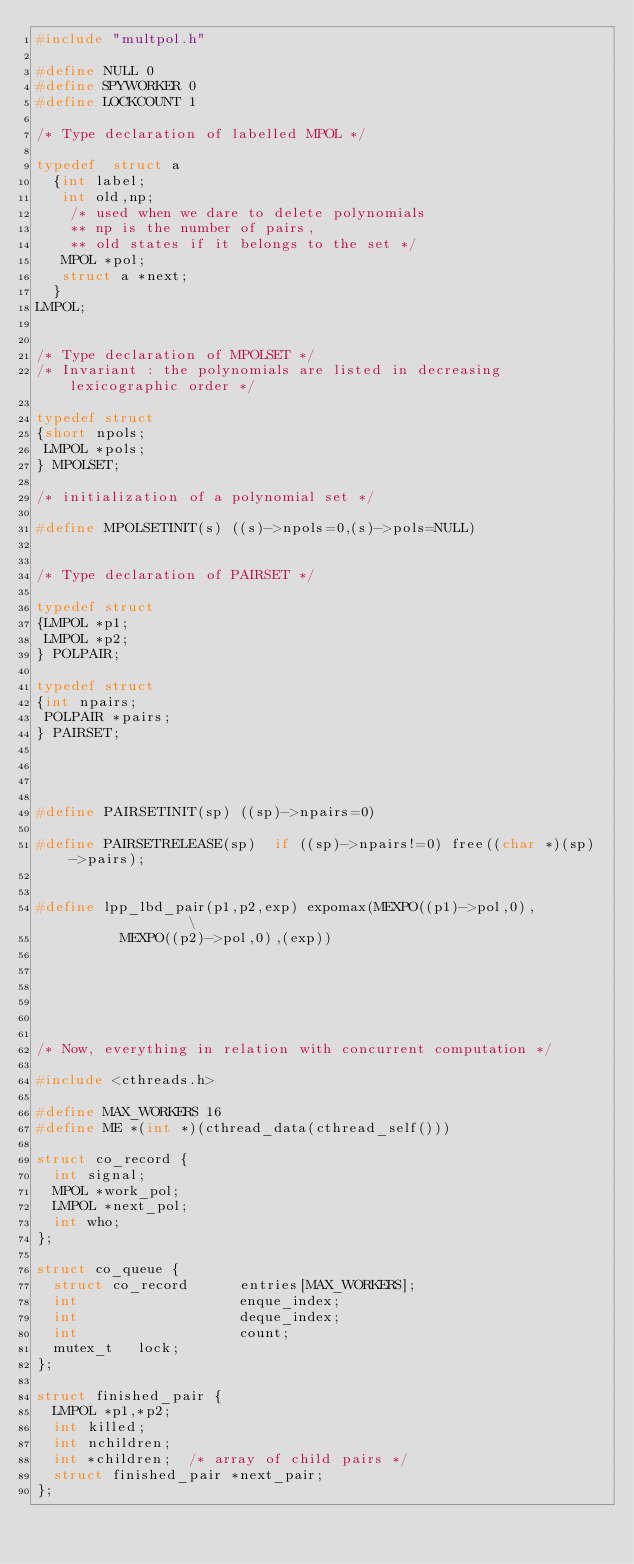Convert code to text. <code><loc_0><loc_0><loc_500><loc_500><_C_>#include "multpol.h"

#define NULL 0
#define SPYWORKER 0
#define LOCKCOUNT 1

/* Type declaration of labelled MPOL */

typedef  struct a
	{int label;
	 int old,np;
		/* used when we dare to delete polynomials 
		** np is the number of pairs, 
		** old states if it belongs to the set */
	 MPOL *pol;
	 struct a *next;
	}
LMPOL;


/* Type declaration of MPOLSET */
/* Invariant : the polynomials are listed in decreasing lexicographic order */

typedef struct
{short npols;
 LMPOL *pols;
} MPOLSET;

/* initialization of a polynomial set */

#define MPOLSETINIT(s) ((s)->npols=0,(s)->pols=NULL)


/* Type declaration of PAIRSET */

typedef struct
{LMPOL *p1;
 LMPOL *p2;
} POLPAIR;

typedef struct
{int npairs;
 POLPAIR *pairs;
} PAIRSET;




#define PAIRSETINIT(sp) ((sp)->npairs=0) 
	
#define PAIRSETRELEASE(sp)  if ((sp)->npairs!=0) free((char *)(sp)->pairs);


#define lpp_lbd_pair(p1,p2,exp) expomax(MEXPO((p1)->pol,0),               \
					MEXPO((p2)->pol,0),(exp))






/* Now, everything in relation with concurrent computation */

#include <cthreads.h>

#define MAX_WORKERS 16
#define ME *(int *)(cthread_data(cthread_self()))

struct co_record {
  int signal;
  MPOL *work_pol;
  LMPOL *next_pol;
  int who;
};

struct co_queue {
  struct co_record      entries[MAX_WORKERS];
  int                   enque_index;
  int                   deque_index;
  int                   count;
  mutex_t		lock;
};

struct finished_pair {
  LMPOL	*p1,*p2;
  int	killed;
  int	nchildren;
  int	*children;	/* array of child pairs */
  struct finished_pair *next_pair;
};
</code> 